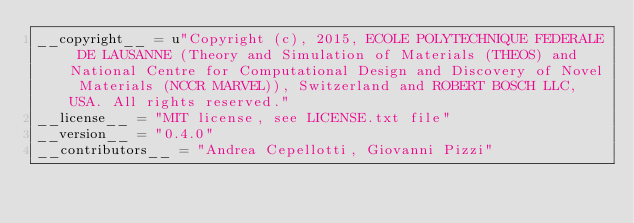Convert code to text. <code><loc_0><loc_0><loc_500><loc_500><_Python_>__copyright__ = u"Copyright (c), 2015, ECOLE POLYTECHNIQUE FEDERALE DE LAUSANNE (Theory and Simulation of Materials (THEOS) and National Centre for Computational Design and Discovery of Novel Materials (NCCR MARVEL)), Switzerland and ROBERT BOSCH LLC, USA. All rights reserved."
__license__ = "MIT license, see LICENSE.txt file"
__version__ = "0.4.0"
__contributors__ = "Andrea Cepellotti, Giovanni Pizzi"

</code> 